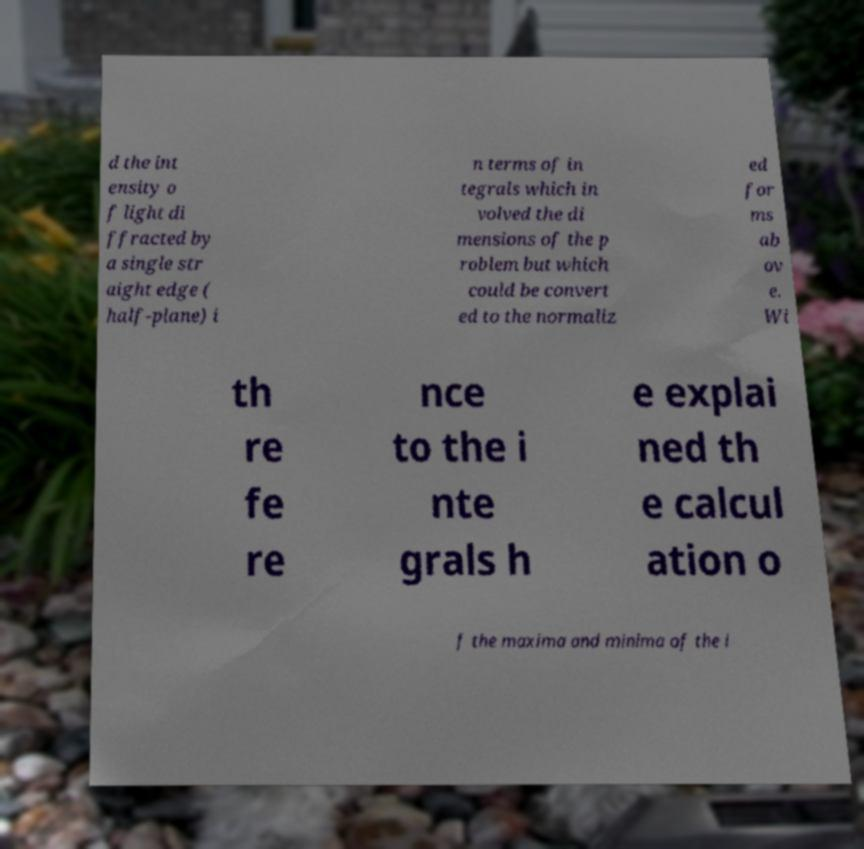For documentation purposes, I need the text within this image transcribed. Could you provide that? d the int ensity o f light di ffracted by a single str aight edge ( half-plane) i n terms of in tegrals which in volved the di mensions of the p roblem but which could be convert ed to the normaliz ed for ms ab ov e. Wi th re fe re nce to the i nte grals h e explai ned th e calcul ation o f the maxima and minima of the i 